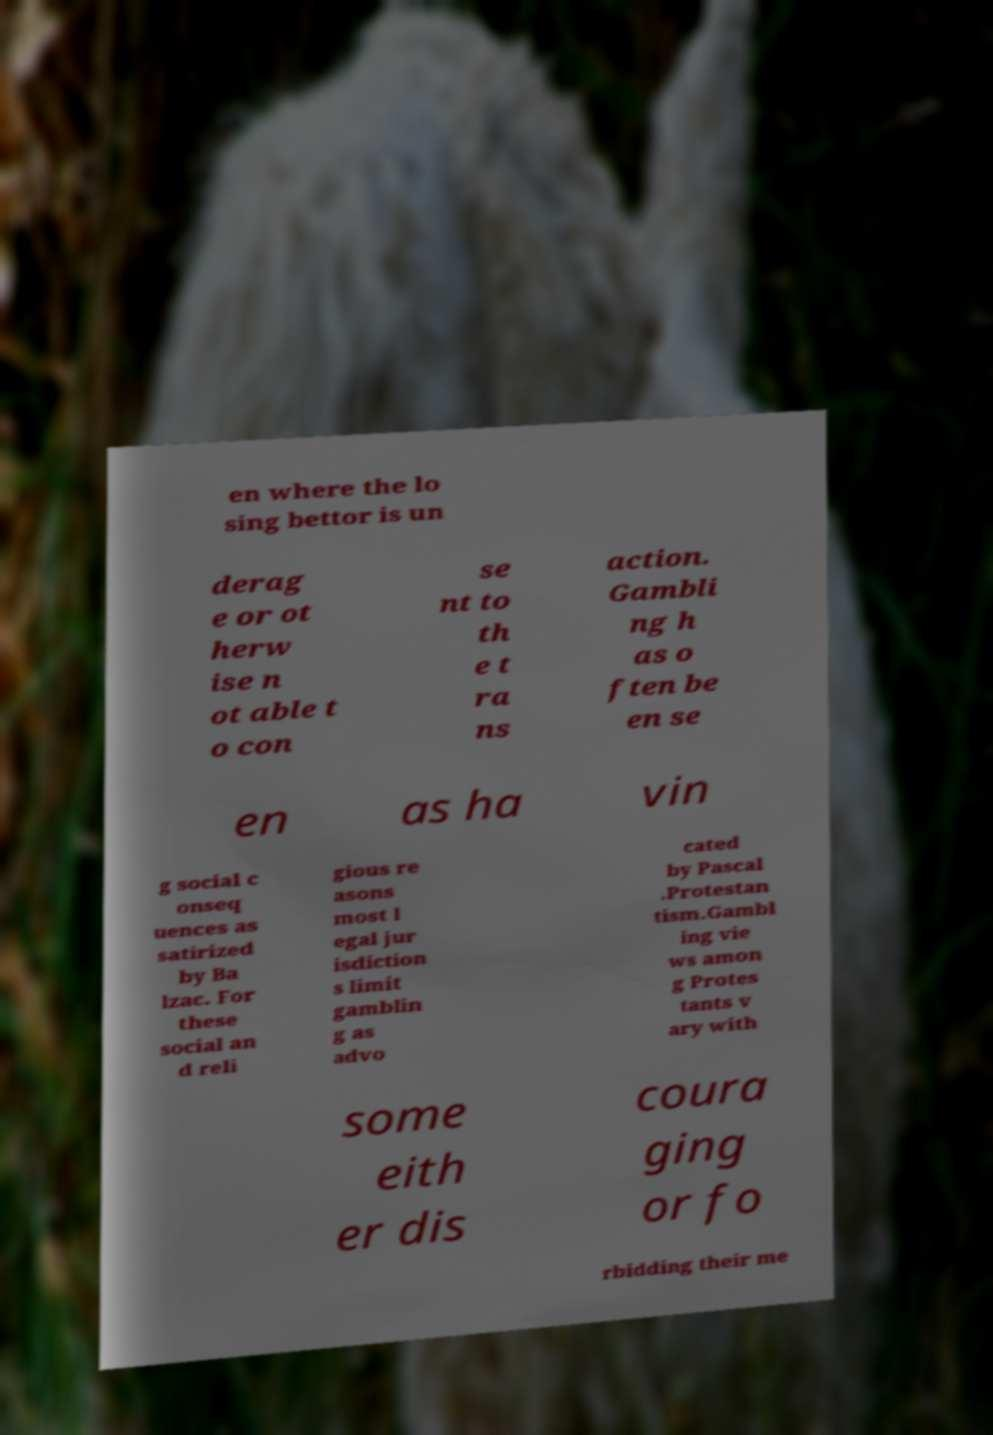Please identify and transcribe the text found in this image. en where the lo sing bettor is un derag e or ot herw ise n ot able t o con se nt to th e t ra ns action. Gambli ng h as o ften be en se en as ha vin g social c onseq uences as satirized by Ba lzac. For these social an d reli gious re asons most l egal jur isdiction s limit gamblin g as advo cated by Pascal .Protestan tism.Gambl ing vie ws amon g Protes tants v ary with some eith er dis coura ging or fo rbidding their me 